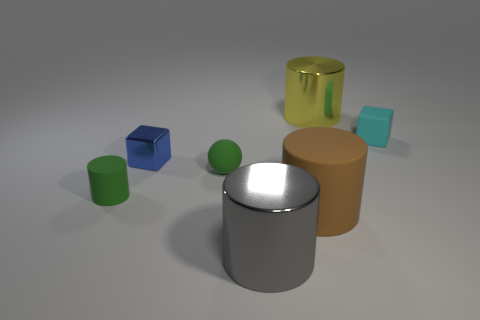Imagine these objects are part of a game, what kind of game could it be? If these were part of a game, it could be a matching or sorting game, where players are required to categorize objects by color, shape, or size. Alternatively, it could be a physics-based puzzle game where players must stack or balance the objects according to specific rules or challenges. 